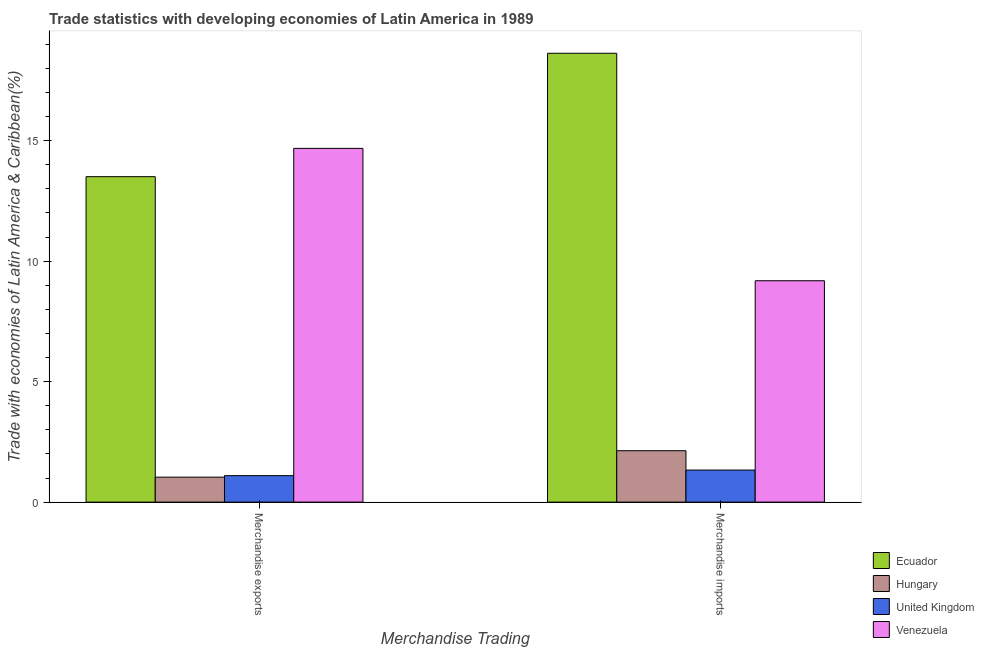How many different coloured bars are there?
Offer a terse response. 4. Are the number of bars per tick equal to the number of legend labels?
Make the answer very short. Yes. Are the number of bars on each tick of the X-axis equal?
Keep it short and to the point. Yes. What is the label of the 1st group of bars from the left?
Your answer should be very brief. Merchandise exports. What is the merchandise imports in Ecuador?
Give a very brief answer. 18.63. Across all countries, what is the maximum merchandise imports?
Make the answer very short. 18.63. Across all countries, what is the minimum merchandise exports?
Provide a short and direct response. 1.04. In which country was the merchandise exports maximum?
Your answer should be compact. Venezuela. In which country was the merchandise imports minimum?
Offer a terse response. United Kingdom. What is the total merchandise imports in the graph?
Offer a very short reply. 31.28. What is the difference between the merchandise imports in Venezuela and that in Ecuador?
Ensure brevity in your answer.  -9.44. What is the difference between the merchandise imports in Hungary and the merchandise exports in Ecuador?
Ensure brevity in your answer.  -11.37. What is the average merchandise exports per country?
Your answer should be compact. 7.58. What is the difference between the merchandise exports and merchandise imports in Venezuela?
Provide a short and direct response. 5.49. What is the ratio of the merchandise imports in United Kingdom to that in Hungary?
Offer a terse response. 0.62. What does the 1st bar from the left in Merchandise imports represents?
Your answer should be compact. Ecuador. What does the 4th bar from the right in Merchandise imports represents?
Keep it short and to the point. Ecuador. How many bars are there?
Offer a very short reply. 8. Are all the bars in the graph horizontal?
Ensure brevity in your answer.  No. What is the difference between two consecutive major ticks on the Y-axis?
Provide a succinct answer. 5. Does the graph contain grids?
Offer a very short reply. No. Where does the legend appear in the graph?
Make the answer very short. Bottom right. What is the title of the graph?
Offer a terse response. Trade statistics with developing economies of Latin America in 1989. What is the label or title of the X-axis?
Keep it short and to the point. Merchandise Trading. What is the label or title of the Y-axis?
Provide a succinct answer. Trade with economies of Latin America & Caribbean(%). What is the Trade with economies of Latin America & Caribbean(%) of Ecuador in Merchandise exports?
Offer a terse response. 13.51. What is the Trade with economies of Latin America & Caribbean(%) of Hungary in Merchandise exports?
Provide a succinct answer. 1.04. What is the Trade with economies of Latin America & Caribbean(%) of United Kingdom in Merchandise exports?
Offer a terse response. 1.1. What is the Trade with economies of Latin America & Caribbean(%) of Venezuela in Merchandise exports?
Give a very brief answer. 14.68. What is the Trade with economies of Latin America & Caribbean(%) of Ecuador in Merchandise imports?
Offer a very short reply. 18.63. What is the Trade with economies of Latin America & Caribbean(%) in Hungary in Merchandise imports?
Your answer should be compact. 2.13. What is the Trade with economies of Latin America & Caribbean(%) in United Kingdom in Merchandise imports?
Your answer should be compact. 1.33. What is the Trade with economies of Latin America & Caribbean(%) in Venezuela in Merchandise imports?
Provide a short and direct response. 9.19. Across all Merchandise Trading, what is the maximum Trade with economies of Latin America & Caribbean(%) in Ecuador?
Provide a short and direct response. 18.63. Across all Merchandise Trading, what is the maximum Trade with economies of Latin America & Caribbean(%) of Hungary?
Your answer should be very brief. 2.13. Across all Merchandise Trading, what is the maximum Trade with economies of Latin America & Caribbean(%) in United Kingdom?
Offer a very short reply. 1.33. Across all Merchandise Trading, what is the maximum Trade with economies of Latin America & Caribbean(%) in Venezuela?
Offer a terse response. 14.68. Across all Merchandise Trading, what is the minimum Trade with economies of Latin America & Caribbean(%) of Ecuador?
Give a very brief answer. 13.51. Across all Merchandise Trading, what is the minimum Trade with economies of Latin America & Caribbean(%) in Hungary?
Keep it short and to the point. 1.04. Across all Merchandise Trading, what is the minimum Trade with economies of Latin America & Caribbean(%) of United Kingdom?
Offer a terse response. 1.1. Across all Merchandise Trading, what is the minimum Trade with economies of Latin America & Caribbean(%) of Venezuela?
Ensure brevity in your answer.  9.19. What is the total Trade with economies of Latin America & Caribbean(%) in Ecuador in the graph?
Provide a succinct answer. 32.14. What is the total Trade with economies of Latin America & Caribbean(%) in Hungary in the graph?
Your answer should be very brief. 3.17. What is the total Trade with economies of Latin America & Caribbean(%) in United Kingdom in the graph?
Give a very brief answer. 2.43. What is the total Trade with economies of Latin America & Caribbean(%) of Venezuela in the graph?
Ensure brevity in your answer.  23.87. What is the difference between the Trade with economies of Latin America & Caribbean(%) in Ecuador in Merchandise exports and that in Merchandise imports?
Ensure brevity in your answer.  -5.12. What is the difference between the Trade with economies of Latin America & Caribbean(%) in Hungary in Merchandise exports and that in Merchandise imports?
Keep it short and to the point. -1.1. What is the difference between the Trade with economies of Latin America & Caribbean(%) of United Kingdom in Merchandise exports and that in Merchandise imports?
Give a very brief answer. -0.23. What is the difference between the Trade with economies of Latin America & Caribbean(%) in Venezuela in Merchandise exports and that in Merchandise imports?
Provide a succinct answer. 5.49. What is the difference between the Trade with economies of Latin America & Caribbean(%) of Ecuador in Merchandise exports and the Trade with economies of Latin America & Caribbean(%) of Hungary in Merchandise imports?
Offer a terse response. 11.37. What is the difference between the Trade with economies of Latin America & Caribbean(%) of Ecuador in Merchandise exports and the Trade with economies of Latin America & Caribbean(%) of United Kingdom in Merchandise imports?
Provide a short and direct response. 12.18. What is the difference between the Trade with economies of Latin America & Caribbean(%) of Ecuador in Merchandise exports and the Trade with economies of Latin America & Caribbean(%) of Venezuela in Merchandise imports?
Your answer should be compact. 4.32. What is the difference between the Trade with economies of Latin America & Caribbean(%) of Hungary in Merchandise exports and the Trade with economies of Latin America & Caribbean(%) of United Kingdom in Merchandise imports?
Provide a short and direct response. -0.29. What is the difference between the Trade with economies of Latin America & Caribbean(%) of Hungary in Merchandise exports and the Trade with economies of Latin America & Caribbean(%) of Venezuela in Merchandise imports?
Provide a succinct answer. -8.15. What is the difference between the Trade with economies of Latin America & Caribbean(%) of United Kingdom in Merchandise exports and the Trade with economies of Latin America & Caribbean(%) of Venezuela in Merchandise imports?
Your answer should be compact. -8.09. What is the average Trade with economies of Latin America & Caribbean(%) of Ecuador per Merchandise Trading?
Your answer should be compact. 16.07. What is the average Trade with economies of Latin America & Caribbean(%) of Hungary per Merchandise Trading?
Ensure brevity in your answer.  1.58. What is the average Trade with economies of Latin America & Caribbean(%) of United Kingdom per Merchandise Trading?
Provide a succinct answer. 1.21. What is the average Trade with economies of Latin America & Caribbean(%) in Venezuela per Merchandise Trading?
Make the answer very short. 11.94. What is the difference between the Trade with economies of Latin America & Caribbean(%) in Ecuador and Trade with economies of Latin America & Caribbean(%) in Hungary in Merchandise exports?
Provide a succinct answer. 12.47. What is the difference between the Trade with economies of Latin America & Caribbean(%) of Ecuador and Trade with economies of Latin America & Caribbean(%) of United Kingdom in Merchandise exports?
Your answer should be very brief. 12.41. What is the difference between the Trade with economies of Latin America & Caribbean(%) of Ecuador and Trade with economies of Latin America & Caribbean(%) of Venezuela in Merchandise exports?
Ensure brevity in your answer.  -1.17. What is the difference between the Trade with economies of Latin America & Caribbean(%) in Hungary and Trade with economies of Latin America & Caribbean(%) in United Kingdom in Merchandise exports?
Provide a succinct answer. -0.06. What is the difference between the Trade with economies of Latin America & Caribbean(%) of Hungary and Trade with economies of Latin America & Caribbean(%) of Venezuela in Merchandise exports?
Give a very brief answer. -13.65. What is the difference between the Trade with economies of Latin America & Caribbean(%) of United Kingdom and Trade with economies of Latin America & Caribbean(%) of Venezuela in Merchandise exports?
Offer a terse response. -13.58. What is the difference between the Trade with economies of Latin America & Caribbean(%) of Ecuador and Trade with economies of Latin America & Caribbean(%) of Hungary in Merchandise imports?
Offer a terse response. 16.5. What is the difference between the Trade with economies of Latin America & Caribbean(%) of Ecuador and Trade with economies of Latin America & Caribbean(%) of United Kingdom in Merchandise imports?
Provide a short and direct response. 17.3. What is the difference between the Trade with economies of Latin America & Caribbean(%) of Ecuador and Trade with economies of Latin America & Caribbean(%) of Venezuela in Merchandise imports?
Offer a terse response. 9.44. What is the difference between the Trade with economies of Latin America & Caribbean(%) in Hungary and Trade with economies of Latin America & Caribbean(%) in United Kingdom in Merchandise imports?
Keep it short and to the point. 0.8. What is the difference between the Trade with economies of Latin America & Caribbean(%) of Hungary and Trade with economies of Latin America & Caribbean(%) of Venezuela in Merchandise imports?
Make the answer very short. -7.06. What is the difference between the Trade with economies of Latin America & Caribbean(%) in United Kingdom and Trade with economies of Latin America & Caribbean(%) in Venezuela in Merchandise imports?
Your answer should be compact. -7.86. What is the ratio of the Trade with economies of Latin America & Caribbean(%) of Ecuador in Merchandise exports to that in Merchandise imports?
Offer a very short reply. 0.72. What is the ratio of the Trade with economies of Latin America & Caribbean(%) in Hungary in Merchandise exports to that in Merchandise imports?
Offer a very short reply. 0.49. What is the ratio of the Trade with economies of Latin America & Caribbean(%) of United Kingdom in Merchandise exports to that in Merchandise imports?
Provide a short and direct response. 0.83. What is the ratio of the Trade with economies of Latin America & Caribbean(%) in Venezuela in Merchandise exports to that in Merchandise imports?
Your answer should be very brief. 1.6. What is the difference between the highest and the second highest Trade with economies of Latin America & Caribbean(%) in Ecuador?
Give a very brief answer. 5.12. What is the difference between the highest and the second highest Trade with economies of Latin America & Caribbean(%) in Hungary?
Your answer should be compact. 1.1. What is the difference between the highest and the second highest Trade with economies of Latin America & Caribbean(%) in United Kingdom?
Ensure brevity in your answer.  0.23. What is the difference between the highest and the second highest Trade with economies of Latin America & Caribbean(%) in Venezuela?
Provide a short and direct response. 5.49. What is the difference between the highest and the lowest Trade with economies of Latin America & Caribbean(%) in Ecuador?
Provide a short and direct response. 5.12. What is the difference between the highest and the lowest Trade with economies of Latin America & Caribbean(%) of Hungary?
Offer a terse response. 1.1. What is the difference between the highest and the lowest Trade with economies of Latin America & Caribbean(%) of United Kingdom?
Offer a very short reply. 0.23. What is the difference between the highest and the lowest Trade with economies of Latin America & Caribbean(%) in Venezuela?
Offer a terse response. 5.49. 